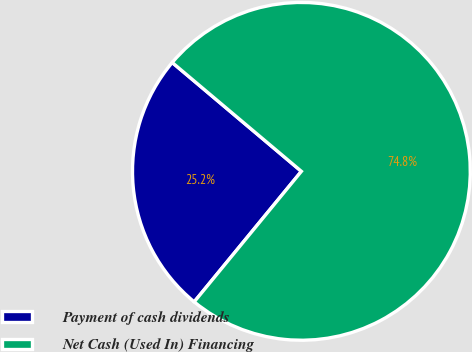Convert chart. <chart><loc_0><loc_0><loc_500><loc_500><pie_chart><fcel>Payment of cash dividends<fcel>Net Cash (Used In) Financing<nl><fcel>25.2%<fcel>74.8%<nl></chart> 